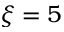Convert formula to latex. <formula><loc_0><loc_0><loc_500><loc_500>\xi = 5</formula> 